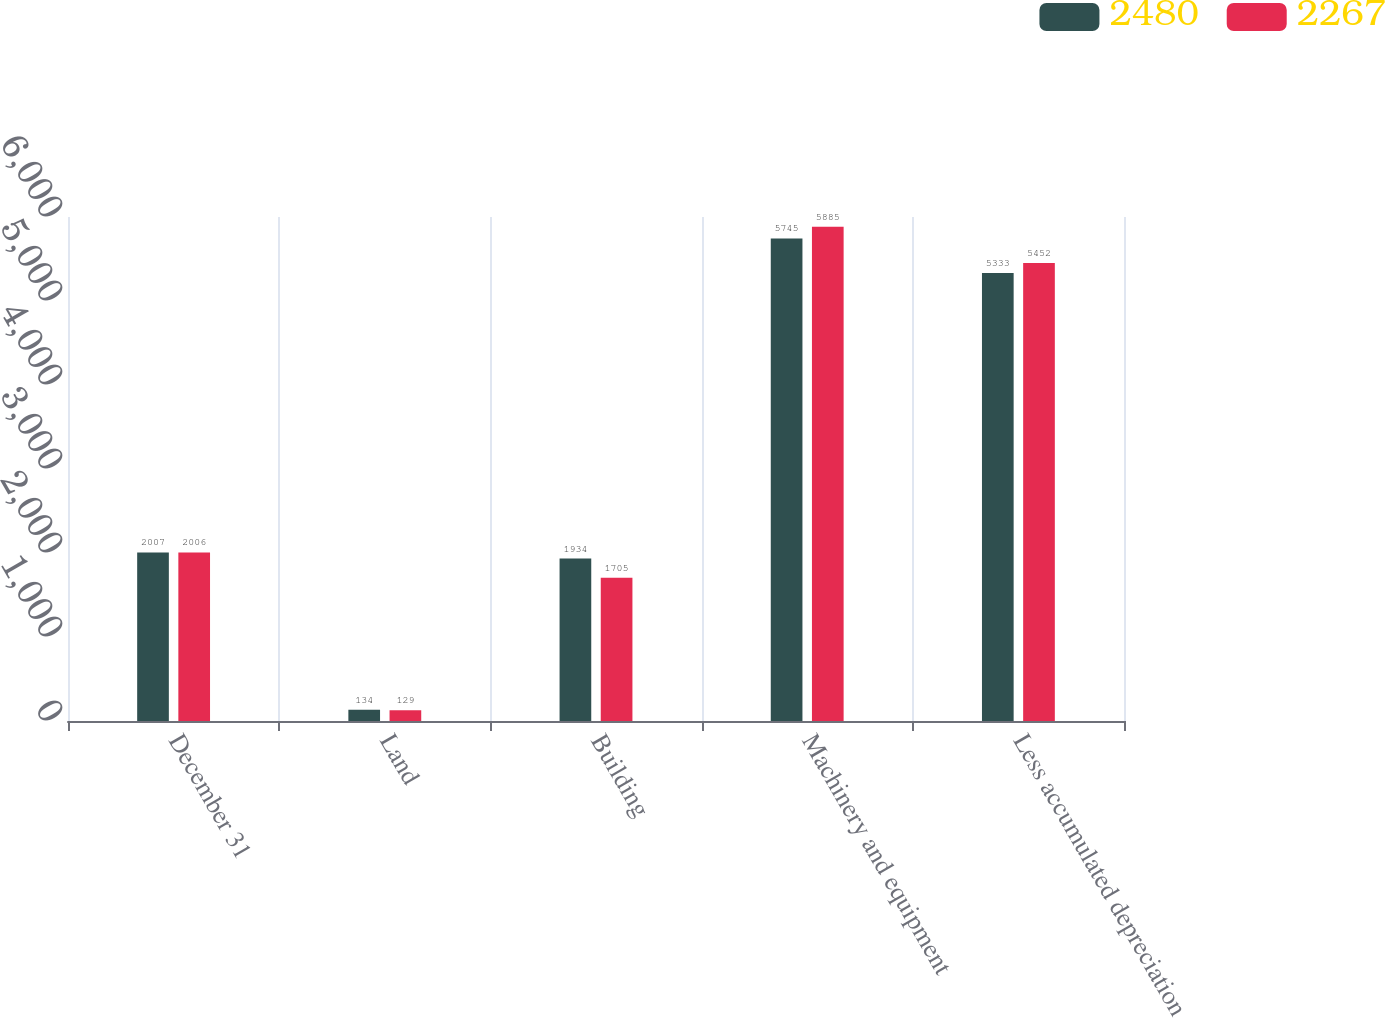Convert chart to OTSL. <chart><loc_0><loc_0><loc_500><loc_500><stacked_bar_chart><ecel><fcel>December 31<fcel>Land<fcel>Building<fcel>Machinery and equipment<fcel>Less accumulated depreciation<nl><fcel>2480<fcel>2007<fcel>134<fcel>1934<fcel>5745<fcel>5333<nl><fcel>2267<fcel>2006<fcel>129<fcel>1705<fcel>5885<fcel>5452<nl></chart> 